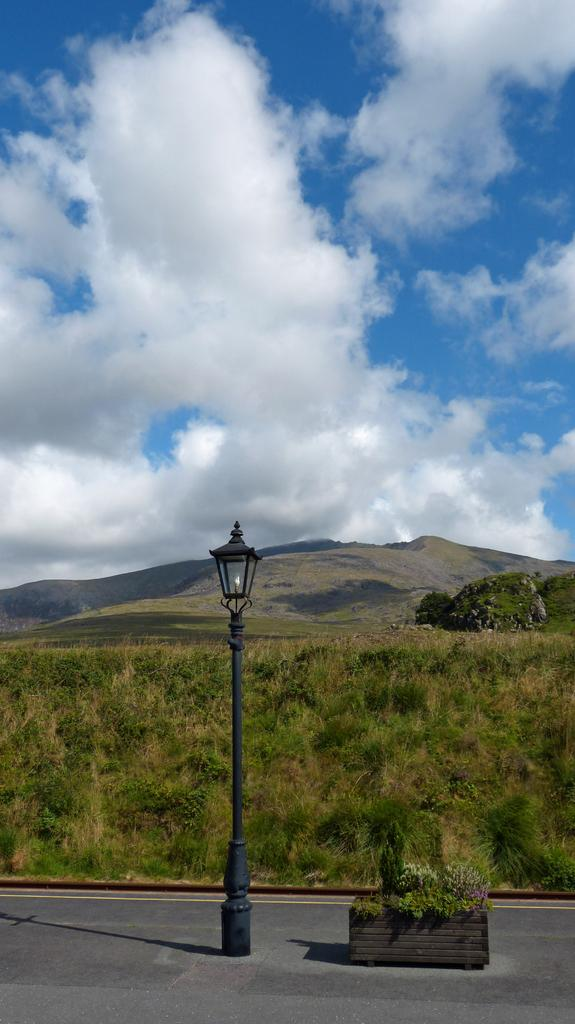What structure is present in the image? There is a light pole in the image. What can be seen in the background of the image? There are trees and grass in the background of the image. What is the color of the trees and grass? The trees and grass are green. What is visible above the trees and grass in the image? The sky is visible in the image. What are the colors of the sky in the image? The sky is blue and white. What type of meat is hanging from the light pole in the image? There is no meat present in the image. 